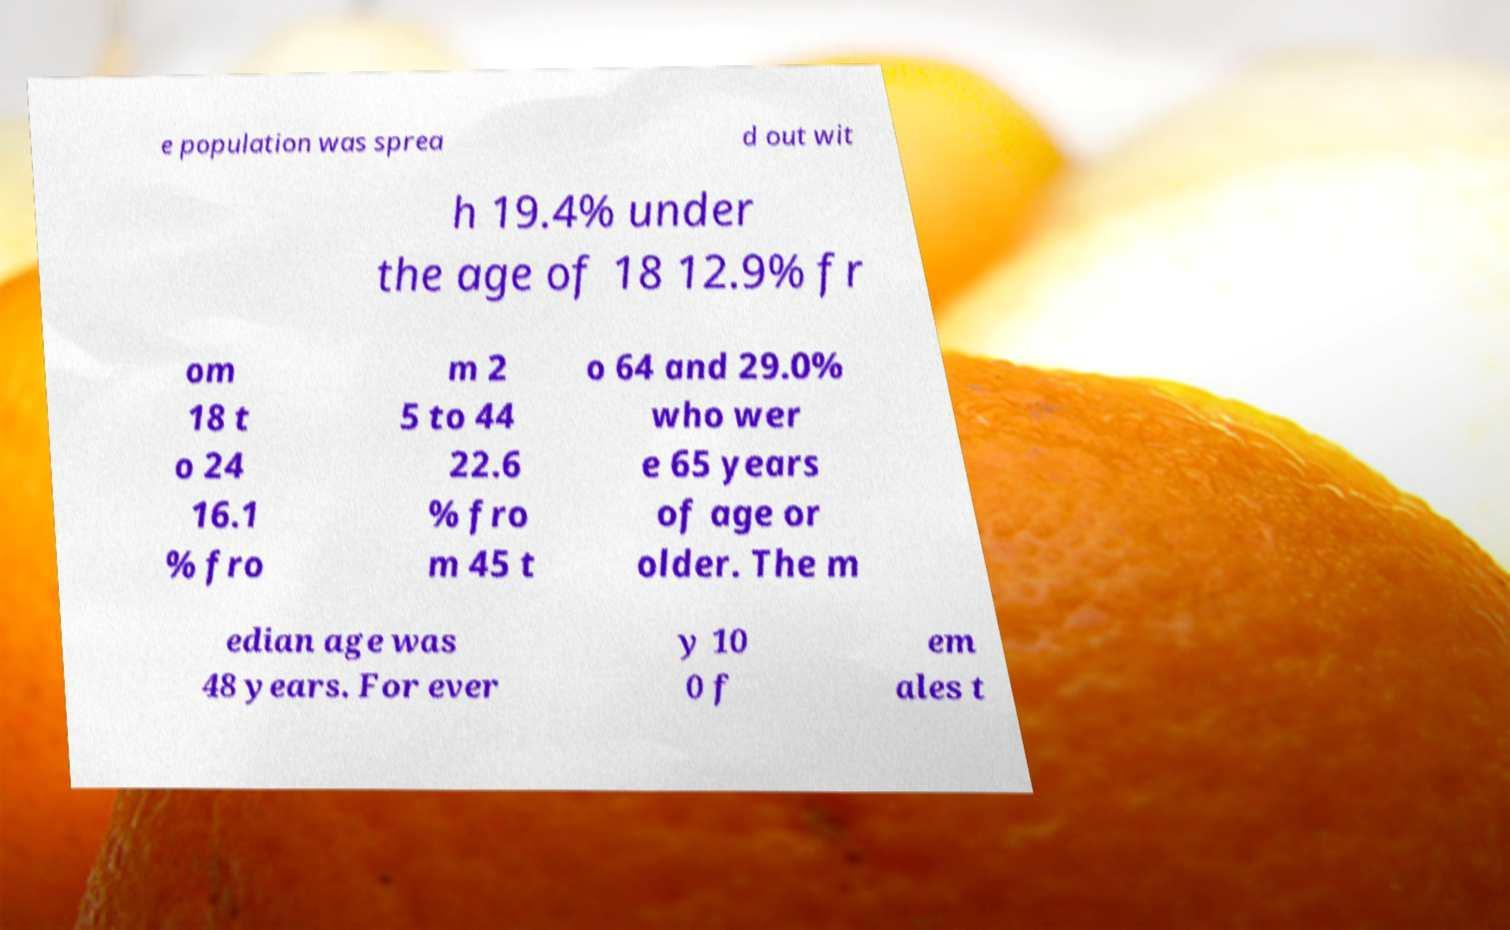For documentation purposes, I need the text within this image transcribed. Could you provide that? e population was sprea d out wit h 19.4% under the age of 18 12.9% fr om 18 t o 24 16.1 % fro m 2 5 to 44 22.6 % fro m 45 t o 64 and 29.0% who wer e 65 years of age or older. The m edian age was 48 years. For ever y 10 0 f em ales t 